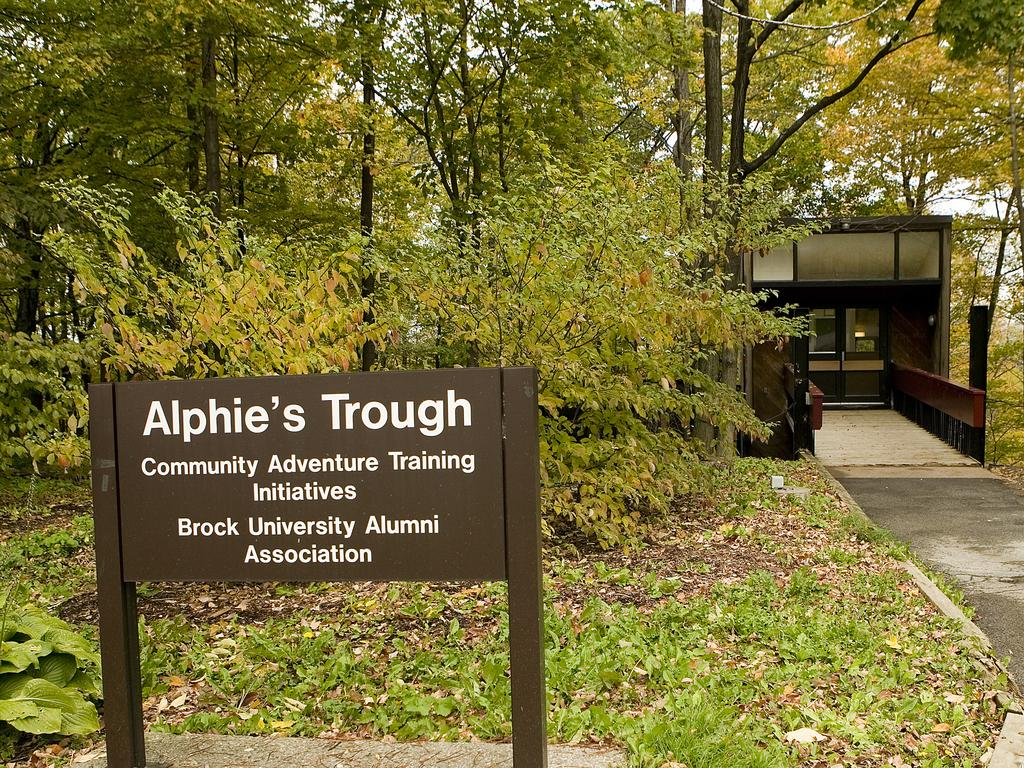What is located in the foreground of the image? There is a board in the foreground of the image. What can be seen in the background of the image? There are trees and a bridge in the background of the image. Is there any structure visible on the right side of the image? Yes, there appears to be a shelter on the right side of the image. What type of path can be seen in the background of the image? There is a path visible in the background of the image. What type of railway is visible in the image? There is no railway present in the image. What mode of transport is used for the voyage depicted in the image? There is no voyage or transport depicted in the image. 